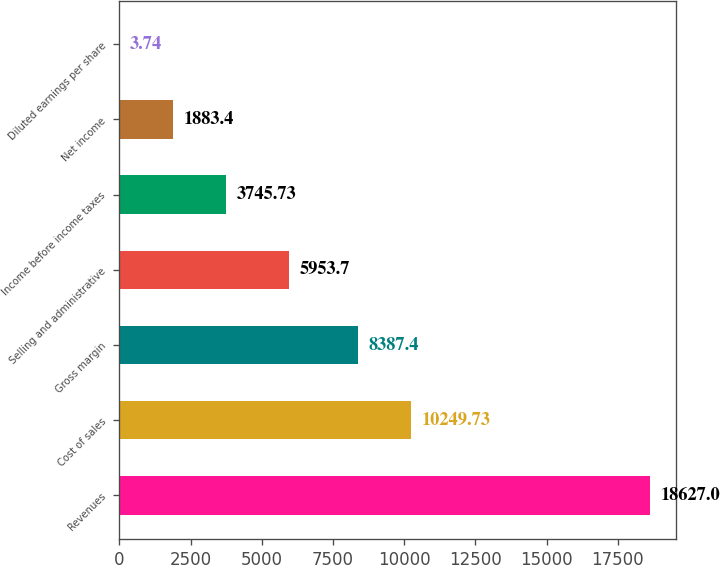Convert chart to OTSL. <chart><loc_0><loc_0><loc_500><loc_500><bar_chart><fcel>Revenues<fcel>Cost of sales<fcel>Gross margin<fcel>Selling and administrative<fcel>Income before income taxes<fcel>Net income<fcel>Diluted earnings per share<nl><fcel>18627<fcel>10249.7<fcel>8387.4<fcel>5953.7<fcel>3745.73<fcel>1883.4<fcel>3.74<nl></chart> 